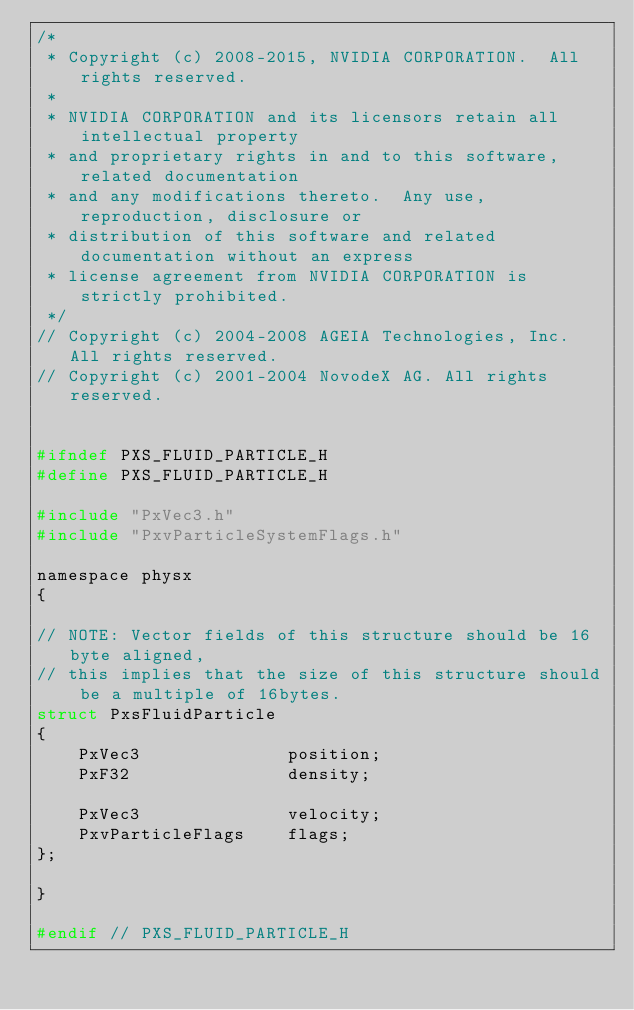<code> <loc_0><loc_0><loc_500><loc_500><_C_>/*
 * Copyright (c) 2008-2015, NVIDIA CORPORATION.  All rights reserved.
 *
 * NVIDIA CORPORATION and its licensors retain all intellectual property
 * and proprietary rights in and to this software, related documentation
 * and any modifications thereto.  Any use, reproduction, disclosure or
 * distribution of this software and related documentation without an express
 * license agreement from NVIDIA CORPORATION is strictly prohibited.
 */
// Copyright (c) 2004-2008 AGEIA Technologies, Inc. All rights reserved.
// Copyright (c) 2001-2004 NovodeX AG. All rights reserved.  


#ifndef PXS_FLUID_PARTICLE_H
#define PXS_FLUID_PARTICLE_H

#include "PxVec3.h"
#include "PxvParticleSystemFlags.h"

namespace physx
{

// NOTE: Vector fields of this structure should be 16byte aligned,
// this implies that the size of this structure should be a multiple of 16bytes.
struct PxsFluidParticle
{
	PxVec3				position;
	PxF32				density;

	PxVec3				velocity;
	PxvParticleFlags	flags;
};

}

#endif // PXS_FLUID_PARTICLE_H
</code> 